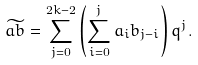<formula> <loc_0><loc_0><loc_500><loc_500>\widetilde { a b } = \sum _ { j = 0 } ^ { 2 k - 2 } \left ( \sum _ { i = 0 } ^ { j } a _ { i } b _ { j - i } \right ) q ^ { j } .</formula> 